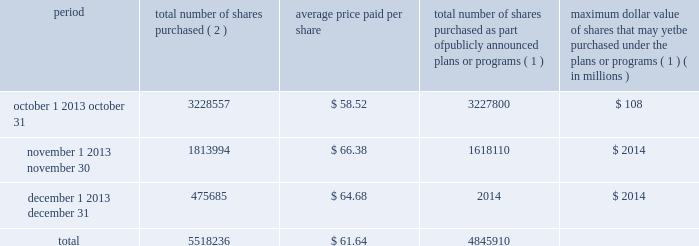Issuer purchases of equity securities the table provides information regarding purchases of our common stock that were made by us during the fourth quarter of 2011 .
Period total number of shares purchased ( 2 ) average price paid per share total number of shares purchased as part of publicly announced plans or programs ( 1 ) maximum dollar value of shares that may yet be purchased under the plans or programs ( 1 ) ( in millions ) .
( 1 ) in may 2010 , our board of directors approved a $ 3.5 billion share repurchase program .
We completed this program in the fourth quarter of 2011 .
In total , we repurchased 49.2 million common shares for $ 3.5 billion , or $ 71.18 per share , under this program .
( 2 ) during the fourth quarter of 2011 , we repurchased 672326 shares from company employees for the payment of personal income tax withholdings resulting from restricted stock vesting and stock option exercises .
Such repurchases are in addition to the $ 3.5 billion repurchase program .
Under the devon energy corporation incentive savings plan ( the 201cplan 201d ) , eligible employees may purchase shares of our common stock through an investment in the devon stock fund ( the 201cstock fund 201d ) , which is administered by an independent trustee , fidelity management trust company .
Eligible employees purchased approximately 45000 shares of our common stock in 2011 , at then-prevailing stock prices , that they held through their ownership in the stock fund .
We acquired the shares of our common stock sold under the plan through open-market purchases .
We filed a registration statement on form s-8 on january 26 , 2012 registering any offers and sales of interests in the plan or the stock fund and of the underlying shares of our common stock purchased by plan participants after that date .
Similarly , under the devon canada corporation savings plan ( the 201ccanadian plan 201d ) , eligible canadian employees may purchase shares of our common stock through an investment in the canadian plan , which is administered by an independent trustee , sun life assurance company of canada .
Eligible canadian employees purchased approximately 9000 shares of our common stock in 2011 , at then-prevailing stock prices , that they held through their ownership in the canadian plan .
We acquired the shares sold under the canadian plan through open-market purchases .
These shares and any interest in the canadian plan were offered and sold in reliance on the exemptions for offers and sales of securities made outside of the u.s. , including under regulation s for offers and sales of securities to employees pursuant to an employee benefit plan established and administered in accordance with the law of a country other than the u.s. .
What was the average change in the share price from october to november? 
Computations: ((66.38 - 58.52) / 58.52)
Answer: 0.13431. Issuer purchases of equity securities the table provides information regarding purchases of our common stock that were made by us during the fourth quarter of 2011 .
Period total number of shares purchased ( 2 ) average price paid per share total number of shares purchased as part of publicly announced plans or programs ( 1 ) maximum dollar value of shares that may yet be purchased under the plans or programs ( 1 ) ( in millions ) .
( 1 ) in may 2010 , our board of directors approved a $ 3.5 billion share repurchase program .
We completed this program in the fourth quarter of 2011 .
In total , we repurchased 49.2 million common shares for $ 3.5 billion , or $ 71.18 per share , under this program .
( 2 ) during the fourth quarter of 2011 , we repurchased 672326 shares from company employees for the payment of personal income tax withholdings resulting from restricted stock vesting and stock option exercises .
Such repurchases are in addition to the $ 3.5 billion repurchase program .
Under the devon energy corporation incentive savings plan ( the 201cplan 201d ) , eligible employees may purchase shares of our common stock through an investment in the devon stock fund ( the 201cstock fund 201d ) , which is administered by an independent trustee , fidelity management trust company .
Eligible employees purchased approximately 45000 shares of our common stock in 2011 , at then-prevailing stock prices , that they held through their ownership in the stock fund .
We acquired the shares of our common stock sold under the plan through open-market purchases .
We filed a registration statement on form s-8 on january 26 , 2012 registering any offers and sales of interests in the plan or the stock fund and of the underlying shares of our common stock purchased by plan participants after that date .
Similarly , under the devon canada corporation savings plan ( the 201ccanadian plan 201d ) , eligible canadian employees may purchase shares of our common stock through an investment in the canadian plan , which is administered by an independent trustee , sun life assurance company of canada .
Eligible canadian employees purchased approximately 9000 shares of our common stock in 2011 , at then-prevailing stock prices , that they held through their ownership in the canadian plan .
We acquired the shares sold under the canadian plan through open-market purchases .
These shares and any interest in the canadian plan were offered and sold in reliance on the exemptions for offers and sales of securities made outside of the u.s. , including under regulation s for offers and sales of securities to employees pursuant to an employee benefit plan established and administered in accordance with the law of a country other than the u.s. .
What percentage of total shares repurchased were purchased in november? 
Computations: (1813994 / 5518236)
Answer: 0.32873. 